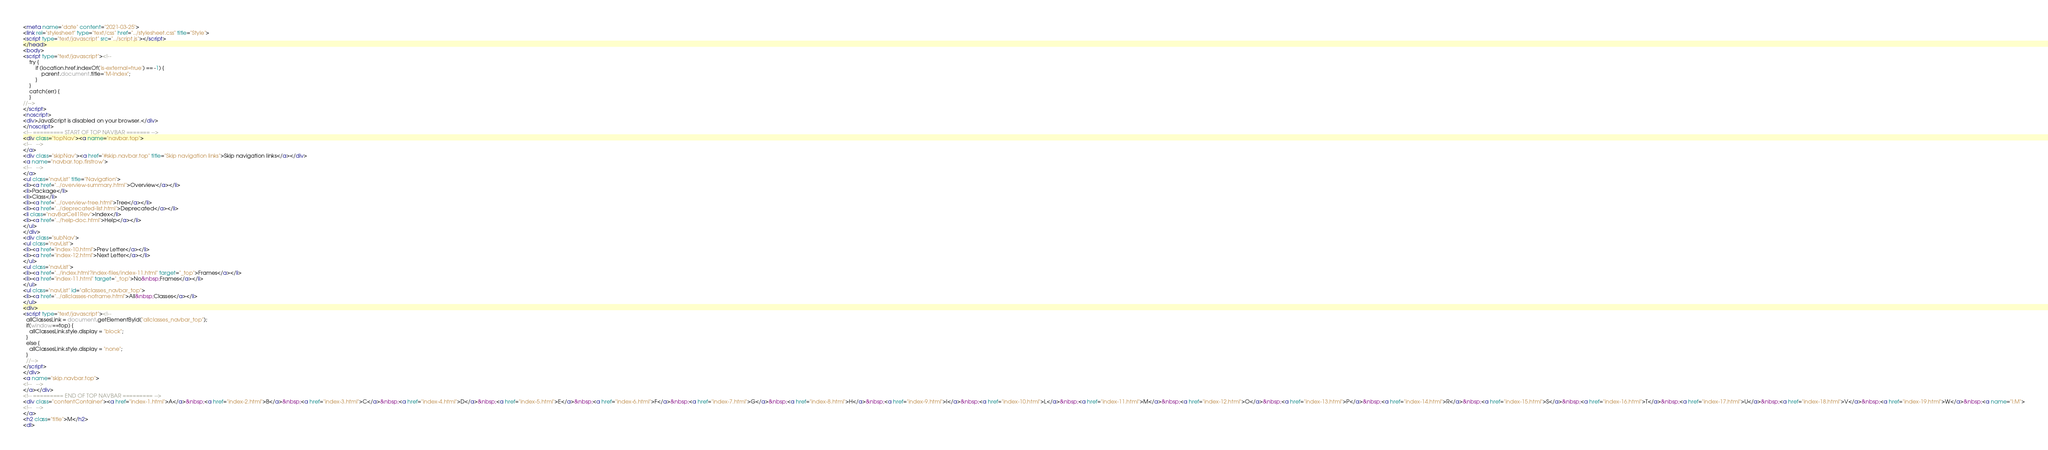<code> <loc_0><loc_0><loc_500><loc_500><_HTML_><meta name="date" content="2021-03-25">
<link rel="stylesheet" type="text/css" href="../stylesheet.css" title="Style">
<script type="text/javascript" src="../script.js"></script>
</head>
<body>
<script type="text/javascript"><!--
    try {
        if (location.href.indexOf('is-external=true') == -1) {
            parent.document.title="M-Index";
        }
    }
    catch(err) {
    }
//-->
</script>
<noscript>
<div>JavaScript is disabled on your browser.</div>
</noscript>
<!-- ========= START OF TOP NAVBAR ======= -->
<div class="topNav"><a name="navbar.top">
<!--   -->
</a>
<div class="skipNav"><a href="#skip.navbar.top" title="Skip navigation links">Skip navigation links</a></div>
<a name="navbar.top.firstrow">
<!--   -->
</a>
<ul class="navList" title="Navigation">
<li><a href="../overview-summary.html">Overview</a></li>
<li>Package</li>
<li>Class</li>
<li><a href="../overview-tree.html">Tree</a></li>
<li><a href="../deprecated-list.html">Deprecated</a></li>
<li class="navBarCell1Rev">Index</li>
<li><a href="../help-doc.html">Help</a></li>
</ul>
</div>
<div class="subNav">
<ul class="navList">
<li><a href="index-10.html">Prev Letter</a></li>
<li><a href="index-12.html">Next Letter</a></li>
</ul>
<ul class="navList">
<li><a href="../index.html?index-files/index-11.html" target="_top">Frames</a></li>
<li><a href="index-11.html" target="_top">No&nbsp;Frames</a></li>
</ul>
<ul class="navList" id="allclasses_navbar_top">
<li><a href="../allclasses-noframe.html">All&nbsp;Classes</a></li>
</ul>
<div>
<script type="text/javascript"><!--
  allClassesLink = document.getElementById("allclasses_navbar_top");
  if(window==top) {
    allClassesLink.style.display = "block";
  }
  else {
    allClassesLink.style.display = "none";
  }
  //-->
</script>
</div>
<a name="skip.navbar.top">
<!--   -->
</a></div>
<!-- ========= END OF TOP NAVBAR ========= -->
<div class="contentContainer"><a href="index-1.html">A</a>&nbsp;<a href="index-2.html">B</a>&nbsp;<a href="index-3.html">C</a>&nbsp;<a href="index-4.html">D</a>&nbsp;<a href="index-5.html">E</a>&nbsp;<a href="index-6.html">F</a>&nbsp;<a href="index-7.html">G</a>&nbsp;<a href="index-8.html">H</a>&nbsp;<a href="index-9.html">I</a>&nbsp;<a href="index-10.html">L</a>&nbsp;<a href="index-11.html">M</a>&nbsp;<a href="index-12.html">O</a>&nbsp;<a href="index-13.html">P</a>&nbsp;<a href="index-14.html">R</a>&nbsp;<a href="index-15.html">S</a>&nbsp;<a href="index-16.html">T</a>&nbsp;<a href="index-17.html">U</a>&nbsp;<a href="index-18.html">V</a>&nbsp;<a href="index-19.html">W</a>&nbsp;<a name="I:M">
<!--   -->
</a>
<h2 class="title">M</h2>
<dl></code> 